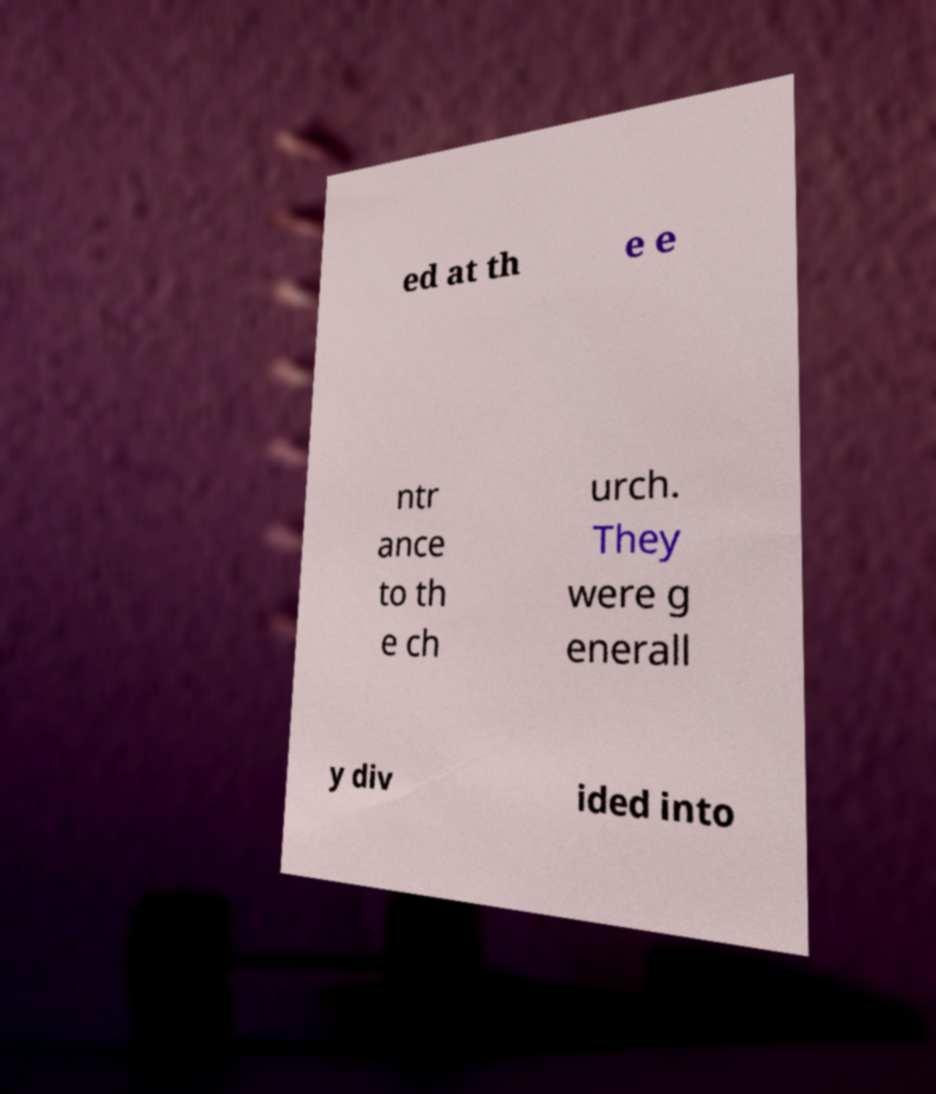What messages or text are displayed in this image? I need them in a readable, typed format. ed at th e e ntr ance to th e ch urch. They were g enerall y div ided into 